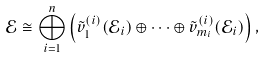<formula> <loc_0><loc_0><loc_500><loc_500>\mathcal { E } \cong \bigoplus _ { i = 1 } ^ { n } \left ( \tilde { v } _ { 1 } ^ { ( i ) } ( \mathcal { E } _ { i } ) \oplus \cdots \oplus \tilde { v } _ { m _ { i } } ^ { ( i ) } ( \mathcal { E } _ { i } ) \right ) ,</formula> 